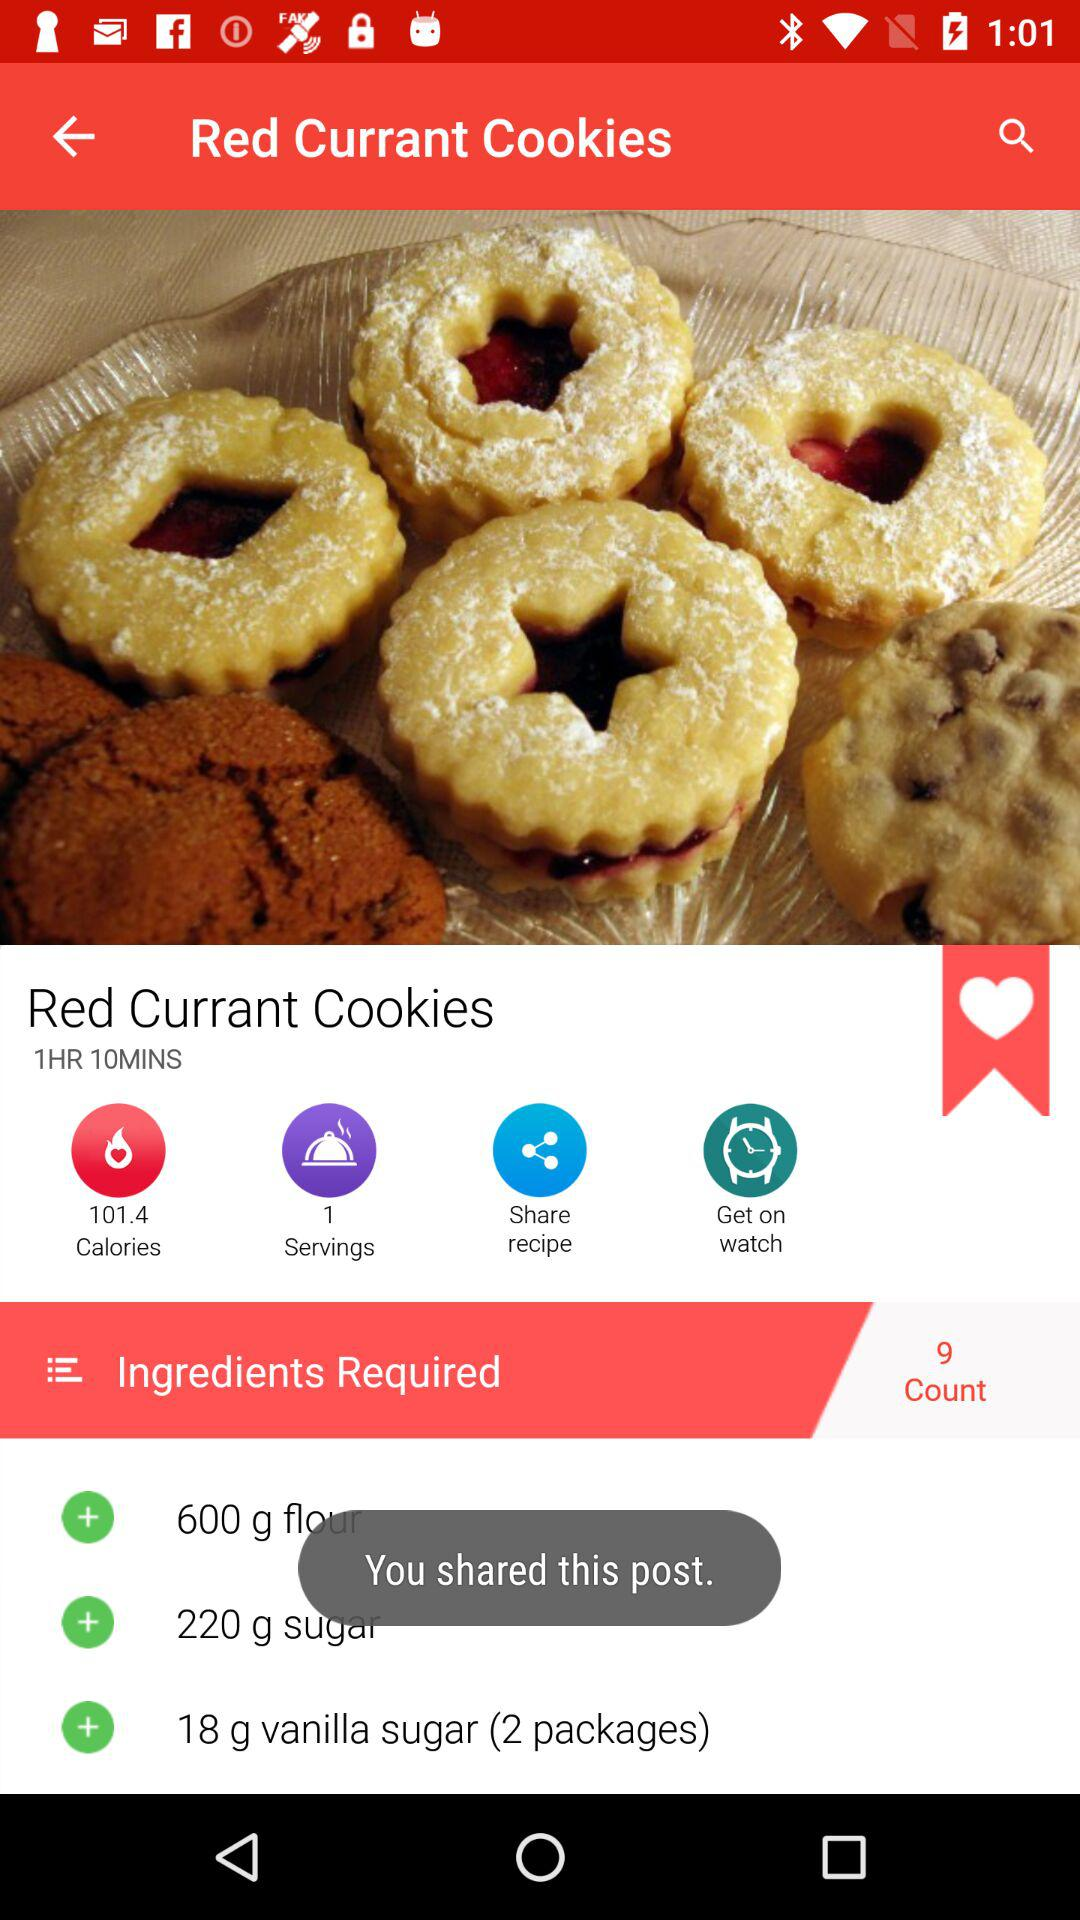What is the cooking time for "Red Currant Cookies"? The cooking time for "Red Currant Cookies" is 1 hour 10 minutes. 